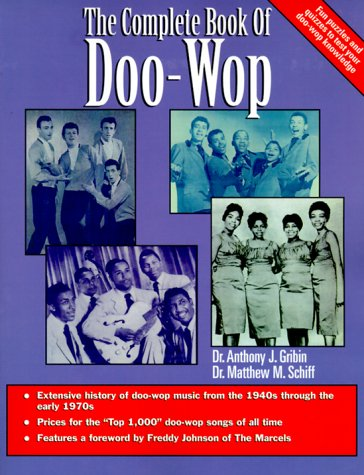What is the genre of this book? Contrary to the earlier classification, this book explores the genre of music, specifically focusing on the Doo-Wop and Rhythm and Blues music styles from the mid-20th century. 